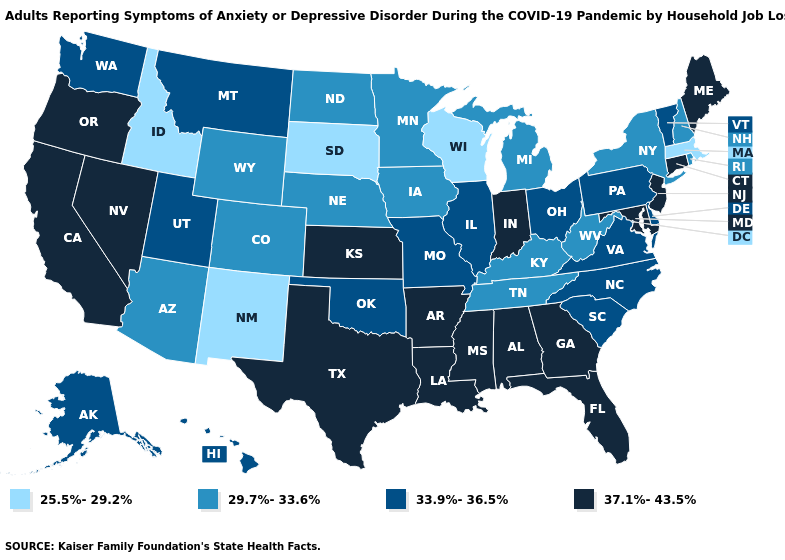Does West Virginia have the same value as Washington?
Write a very short answer. No. What is the lowest value in the USA?
Give a very brief answer. 25.5%-29.2%. What is the value of Massachusetts?
Write a very short answer. 25.5%-29.2%. What is the value of Vermont?
Write a very short answer. 33.9%-36.5%. Does the first symbol in the legend represent the smallest category?
Write a very short answer. Yes. Which states hav the highest value in the MidWest?
Concise answer only. Indiana, Kansas. Name the states that have a value in the range 33.9%-36.5%?
Quick response, please. Alaska, Delaware, Hawaii, Illinois, Missouri, Montana, North Carolina, Ohio, Oklahoma, Pennsylvania, South Carolina, Utah, Vermont, Virginia, Washington. Does Wisconsin have the lowest value in the USA?
Be succinct. Yes. How many symbols are there in the legend?
Be succinct. 4. Is the legend a continuous bar?
Concise answer only. No. Does Illinois have a higher value than Wisconsin?
Write a very short answer. Yes. Name the states that have a value in the range 29.7%-33.6%?
Keep it brief. Arizona, Colorado, Iowa, Kentucky, Michigan, Minnesota, Nebraska, New Hampshire, New York, North Dakota, Rhode Island, Tennessee, West Virginia, Wyoming. Does Texas have the lowest value in the South?
Give a very brief answer. No. Does Maine have the lowest value in the Northeast?
Give a very brief answer. No. What is the value of Mississippi?
Give a very brief answer. 37.1%-43.5%. 